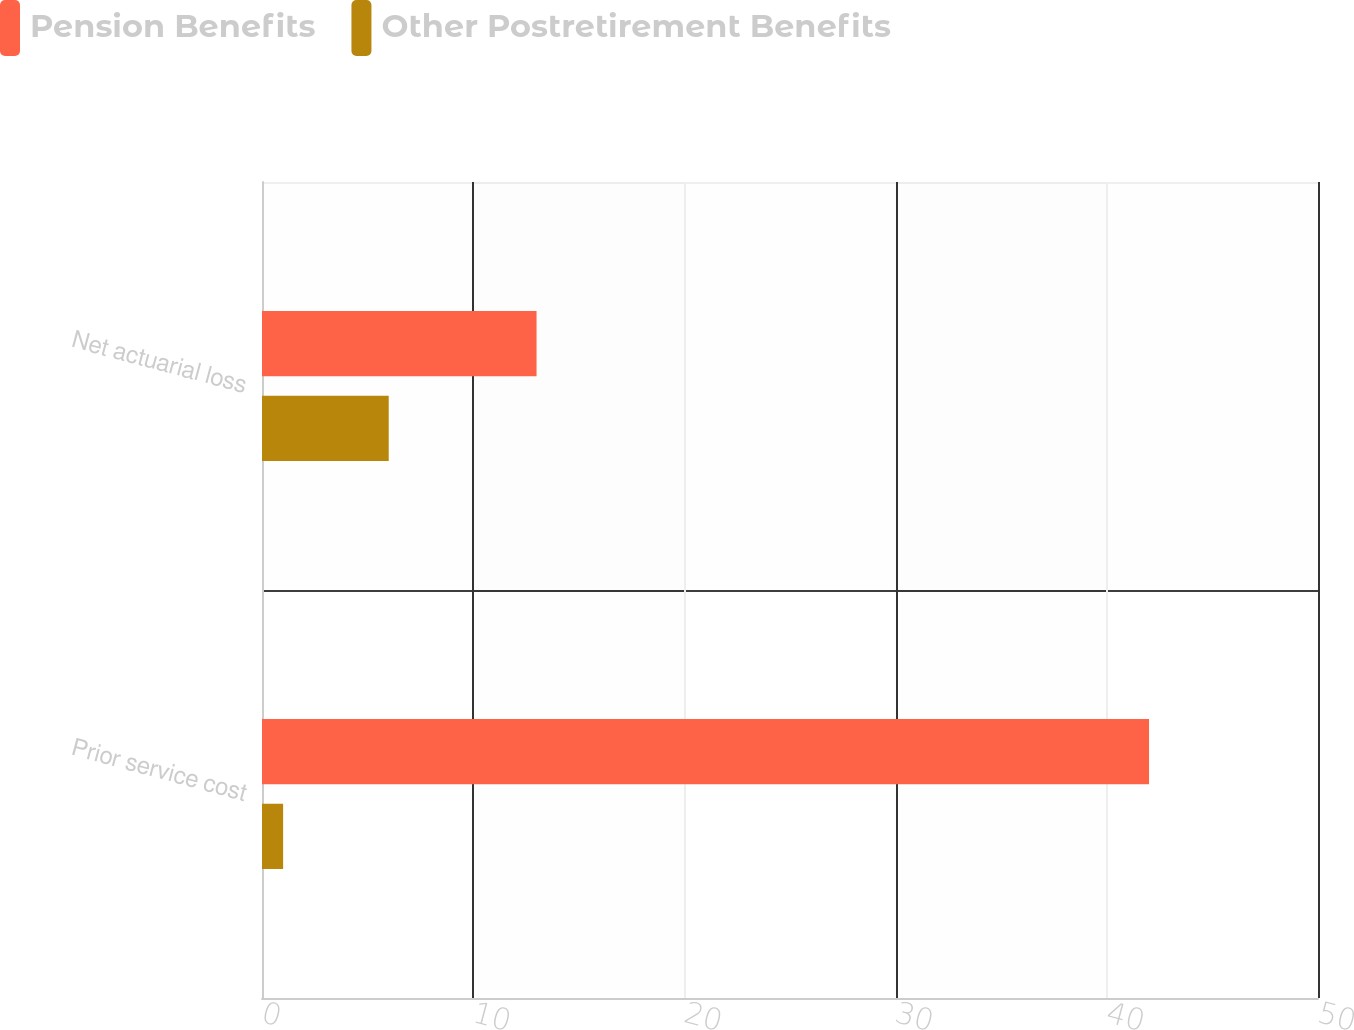Convert chart to OTSL. <chart><loc_0><loc_0><loc_500><loc_500><stacked_bar_chart><ecel><fcel>Prior service cost<fcel>Net actuarial loss<nl><fcel>Pension Benefits<fcel>42<fcel>13<nl><fcel>Other Postretirement Benefits<fcel>1<fcel>6<nl></chart> 